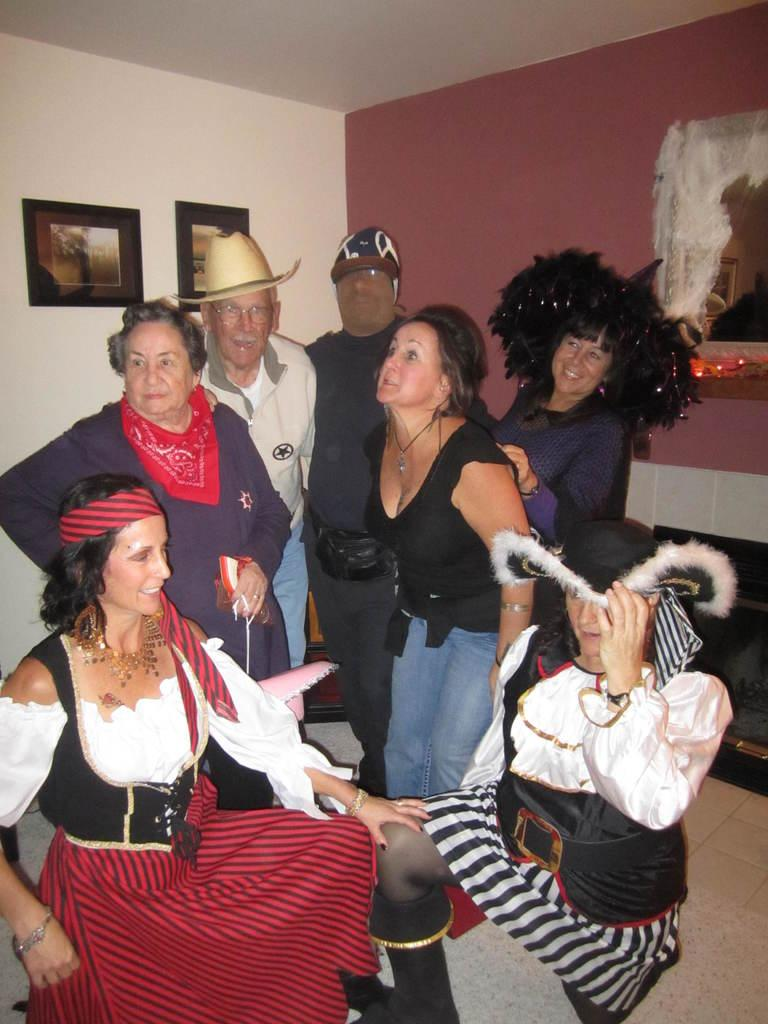What can be observed about the people in the image? There are people with different costumes in the image. Are there any specific accessories worn by the people? Some of the people are wearing hats. What can be seen in the background of the image? There is a wall with photo frames in the background. What object is located on the right side of the image? There is a mirror on the right side of the image. What type of pets are visible in the image? There are no pets visible in the image. What is the straw used for in the image? There is no straw present in the image. 